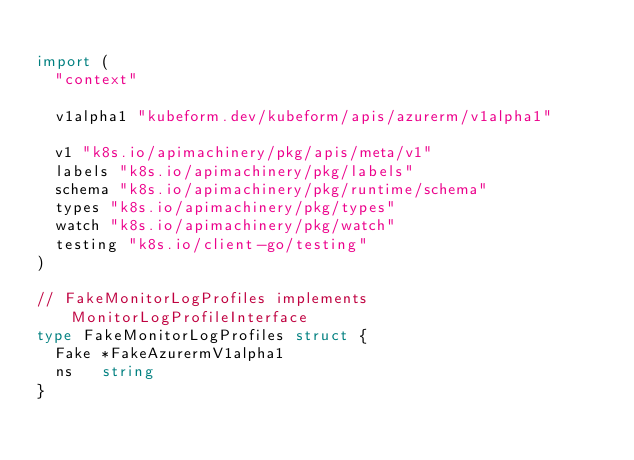<code> <loc_0><loc_0><loc_500><loc_500><_Go_>
import (
	"context"

	v1alpha1 "kubeform.dev/kubeform/apis/azurerm/v1alpha1"

	v1 "k8s.io/apimachinery/pkg/apis/meta/v1"
	labels "k8s.io/apimachinery/pkg/labels"
	schema "k8s.io/apimachinery/pkg/runtime/schema"
	types "k8s.io/apimachinery/pkg/types"
	watch "k8s.io/apimachinery/pkg/watch"
	testing "k8s.io/client-go/testing"
)

// FakeMonitorLogProfiles implements MonitorLogProfileInterface
type FakeMonitorLogProfiles struct {
	Fake *FakeAzurermV1alpha1
	ns   string
}
</code> 